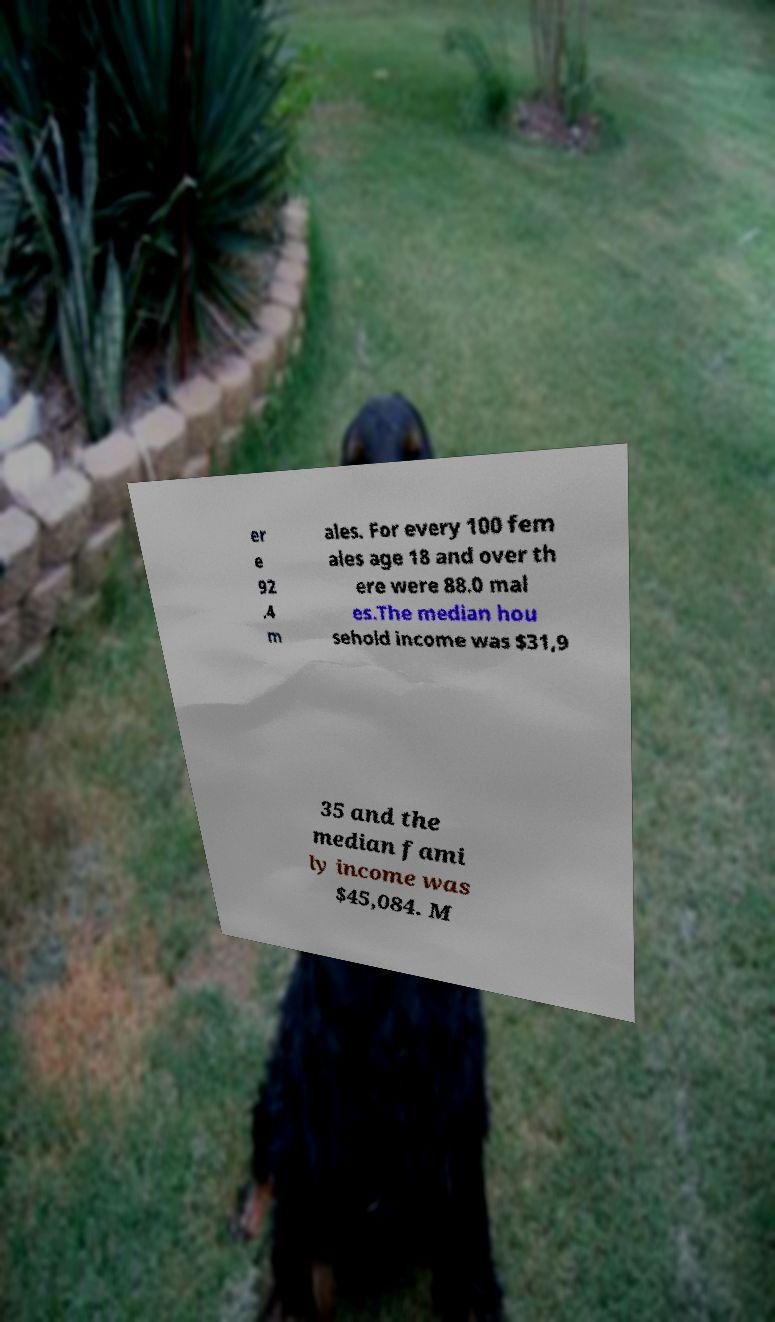Please read and relay the text visible in this image. What does it say? er e 92 .4 m ales. For every 100 fem ales age 18 and over th ere were 88.0 mal es.The median hou sehold income was $31,9 35 and the median fami ly income was $45,084. M 